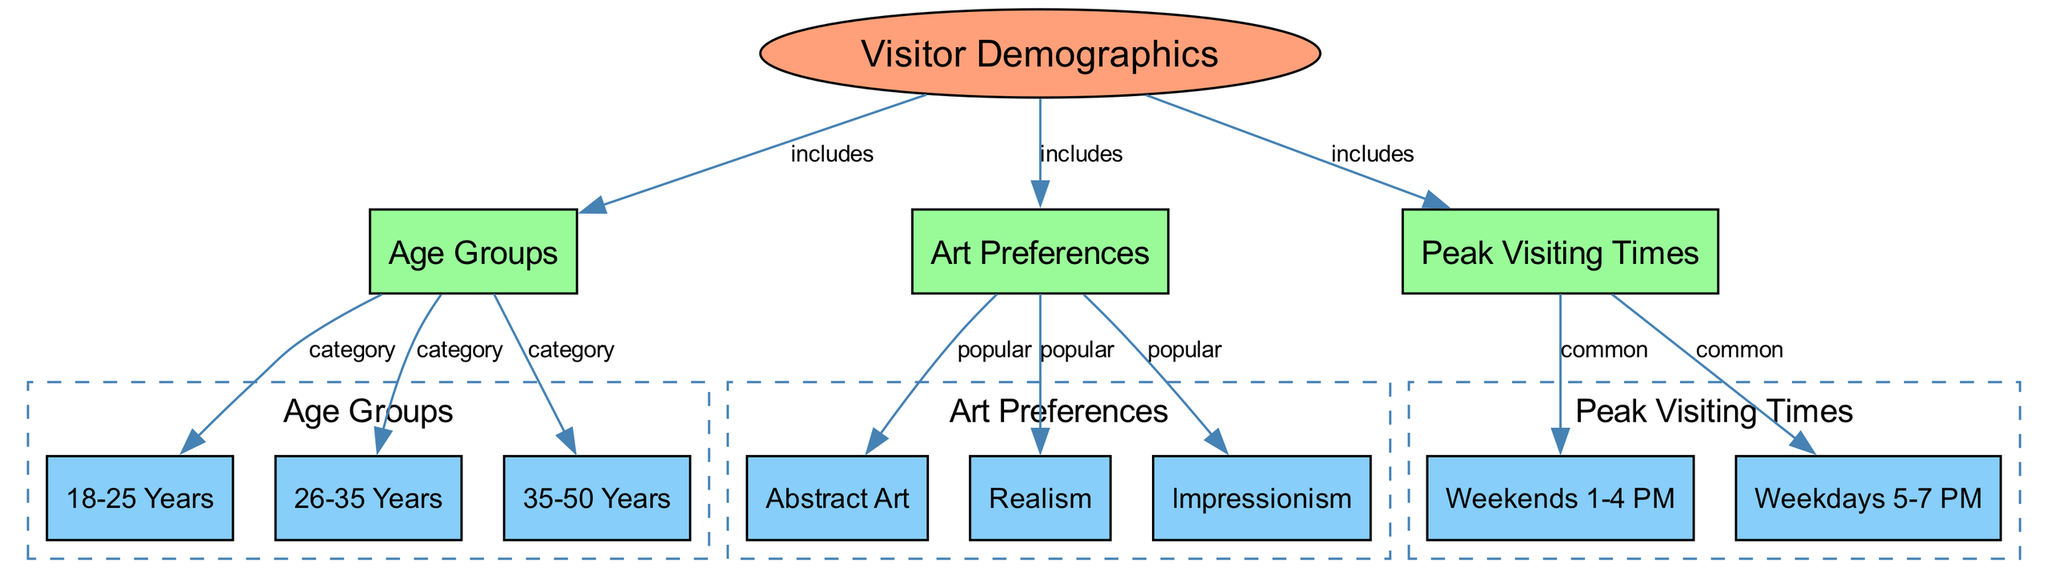What are the three age groups represented in the diagram? The diagram includes three age groups as nodes under "Age Groups," which are "18-25 Years," "26-35 Years," and "35-50 Years."
Answer: 18-25 Years, 26-35 Years, 35-50 Years How many art preferences are listed in the diagram? The diagram shows three art preferences, which are "Abstract Art," "Realism," and "Impressionism." These preferences are directly connected to the "Art Preferences" node.
Answer: 3 What peak visiting time is most common according to the diagram? The diagram indicates two peak visiting times: "Weekends 1-4 PM" and "Weekdays 5-7 PM." Both are categorized as common under "Peak Visiting Times." Determining the most common requires interpreting the information, and here, both options are equally common.
Answer: Weekends 1-4 PM and Weekdays 5-7 PM Which age group is connected to the "Realism" art preference? In the diagram, there is no direct connection between age groups and the "Realism" art preference, but "Realism" is associated with "Art Preferences," which ultimately falls under "Visitor Demographics." Thus, any age group can enjoy "Realism." The question exemplifies how demographics can influence art preferences without a direct link shown.
Answer: 18-25 Years, 26-35 Years, 35-50 Years How many total nodes are in the diagram? Counting all nodes listed, there are 12 total nodes, including the main categories and subcategories within the diagram.
Answer: 12 